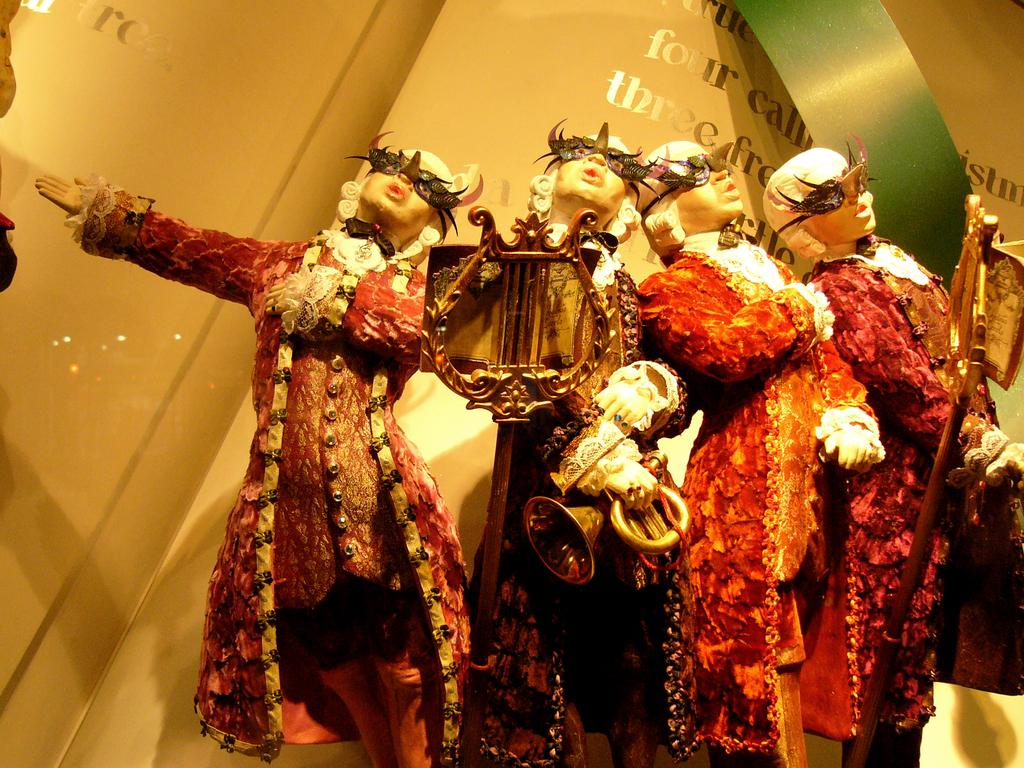What can be seen in the image? There are depictions of persons in the image. What is present in the background of the image? There is a wall with text in the background of the image. What type of stew is being served to the beggar in the image? There is no beggar or stew present in the image. What type of fuel is being used to power the depicted persons in the image? There is no fuel or indication of powering the depicted persons in the image. 